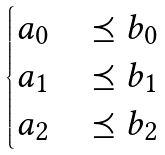<formula> <loc_0><loc_0><loc_500><loc_500>\begin{cases} a _ { 0 } & \, \preceq b _ { 0 } \\ a _ { 1 } & \, \preceq b _ { 1 } \\ a _ { 2 } & \, \preceq b _ { 2 } \end{cases}</formula> 